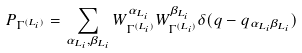Convert formula to latex. <formula><loc_0><loc_0><loc_500><loc_500>P _ { \Gamma ^ { ( L _ { i } ) } } = \sum _ { \alpha _ { L _ { i } } , \beta _ { L _ { i } } } W _ { \Gamma ^ { ( L _ { i } ) } } ^ { \alpha _ { L _ { i } } } W _ { \Gamma ^ { ( L _ { i } ) } } ^ { \beta _ { L _ { i } } } \delta ( q - q _ { \alpha _ { L _ { i } } \beta _ { L _ { i } } } )</formula> 